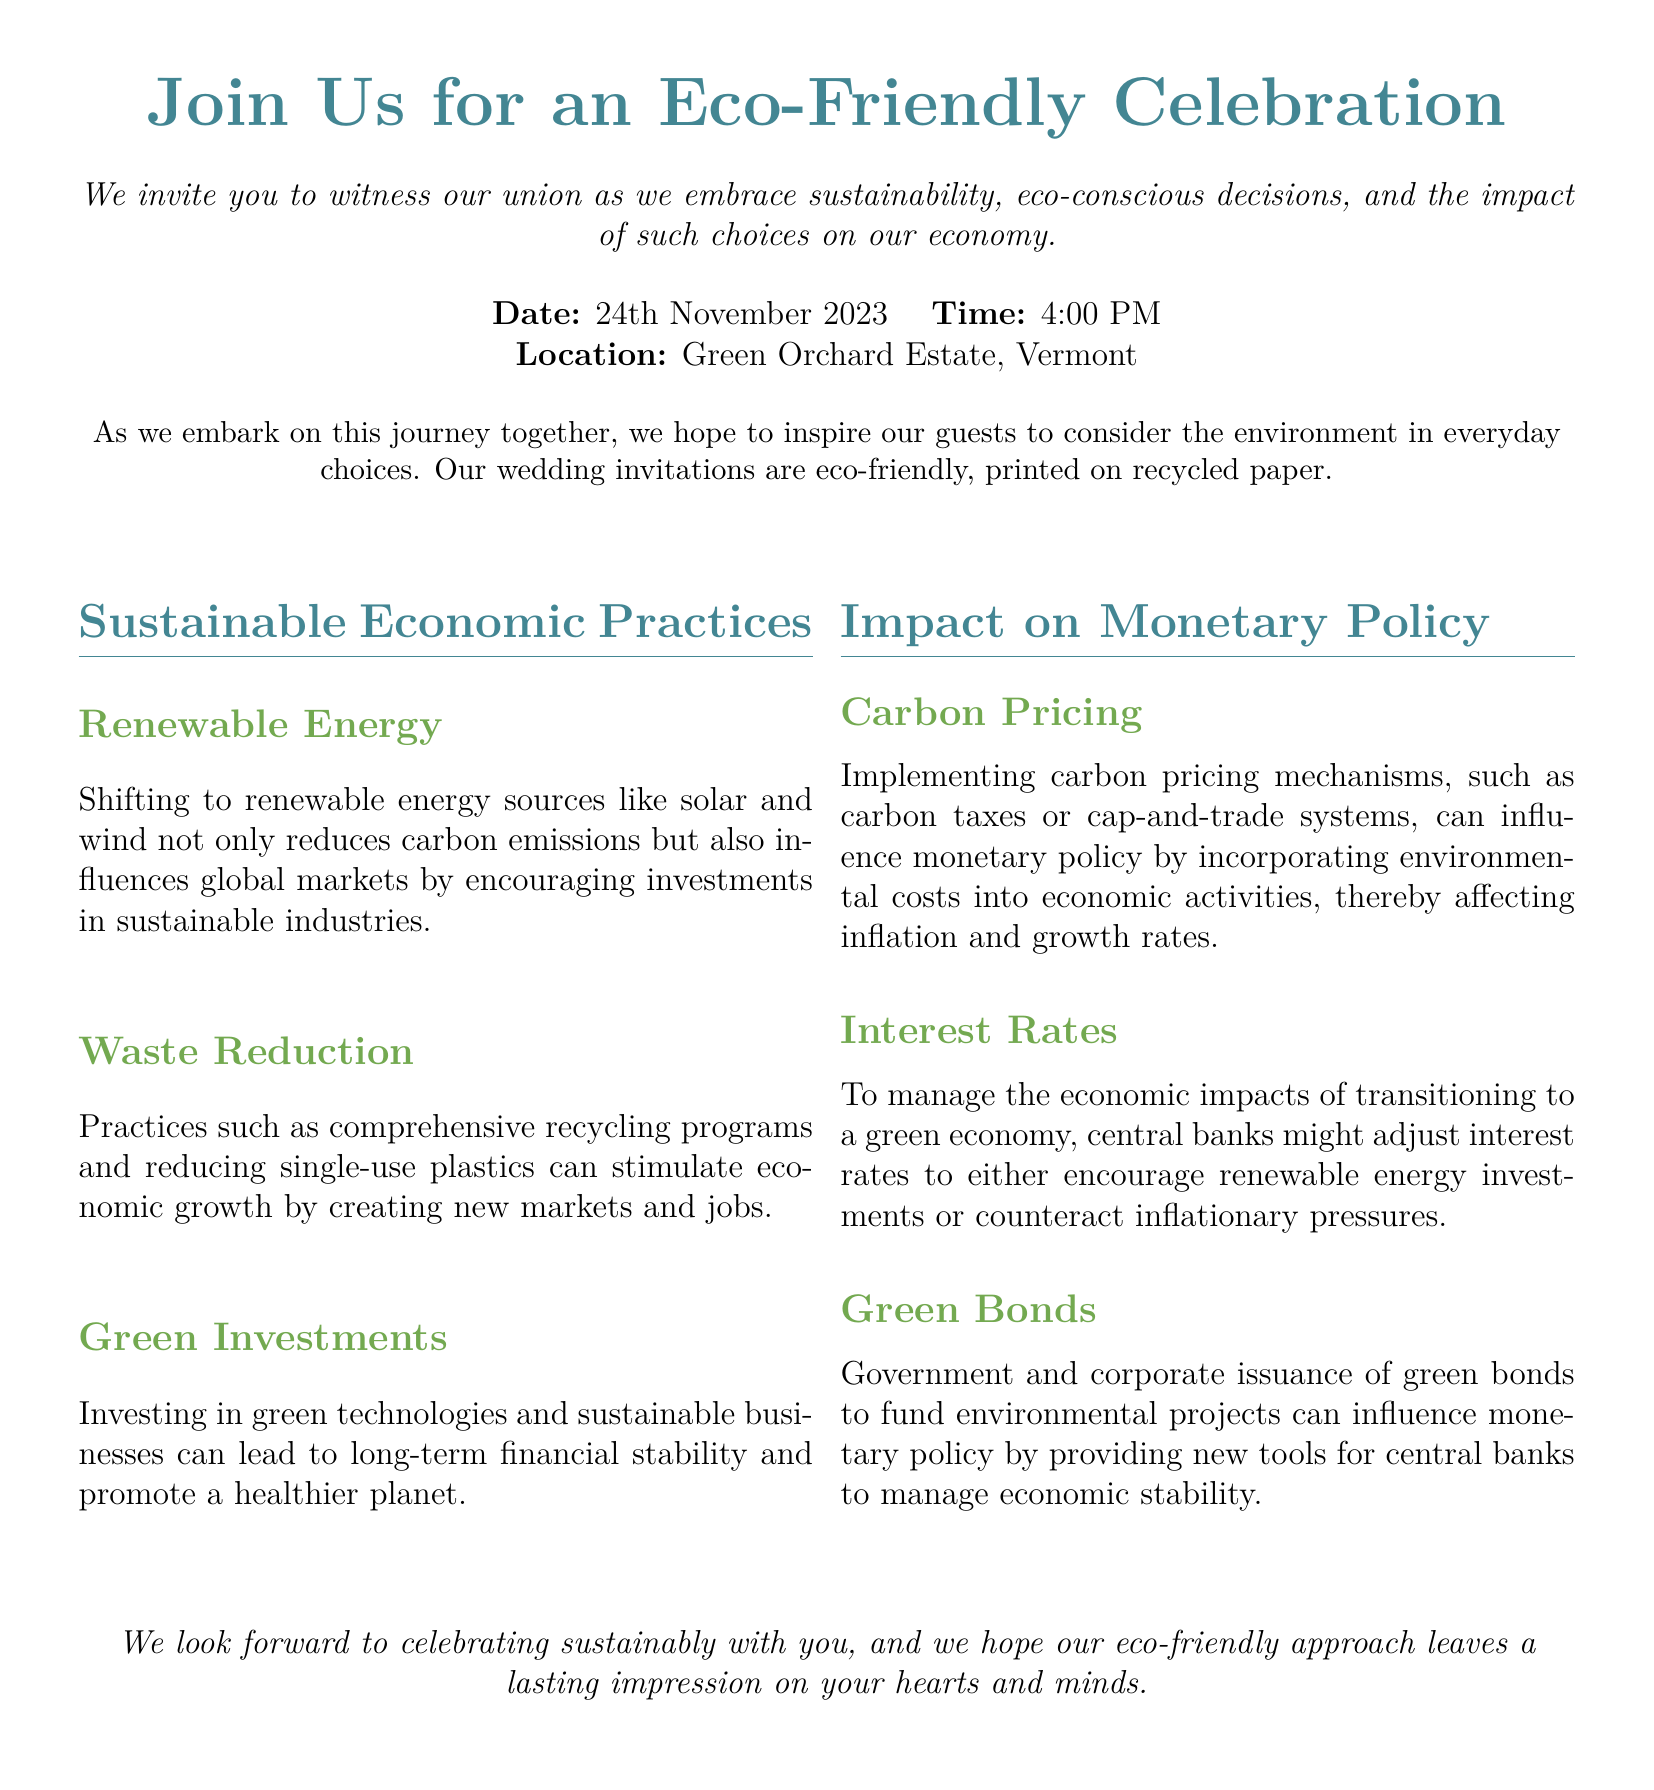what is the date of the wedding? The date of the wedding is explicitly mentioned in the invitation section as November 24th, 2023.
Answer: November 24th, 2023 what is the location of the wedding? The location is provided under the date and time section of the invitation.
Answer: Green Orchard Estate, Vermont what time does the wedding start? The start time for the wedding ceremony is stated clearly along with the date in the invitation.
Answer: 4:00 PM what type of paper is the invitation printed on? The invitation specifies the nature of its production, highlighting its eco-friendly aspect.
Answer: recycled paper what is one example of a sustainable economic practice mentioned? The document lists several sustainable practices; one of them is specified in a subsection.
Answer: Renewable Energy how might carbon pricing affect monetary policy? The invitation provides an explanation of how carbon pricing impacts economic activities and monetary policy aspects.
Answer: influence inflation and growth rates what are green bonds used for? This document describes the purpose of green bonds in relation to economic stability and projects.
Answer: fund environmental projects why is waste reduction important? The document argues about the economic implications of waste reduction and its broader impacts.
Answer: stimulates economic growth what is the theme of the wedding celebration? The overall theme of the wedding celebration is articulated in the opening lines of the invitation.
Answer: eco-friendly celebration 